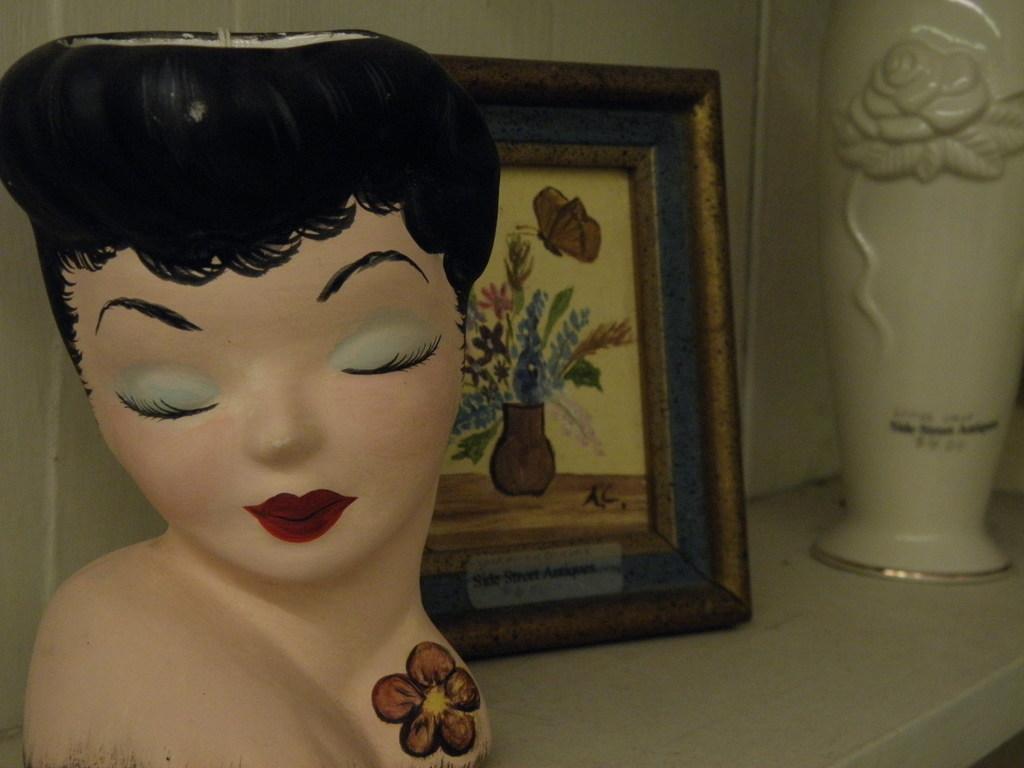Please provide a concise description of this image. In center of the image there is a depiction of a lady, There is a photo frame, There is a flower vase. 